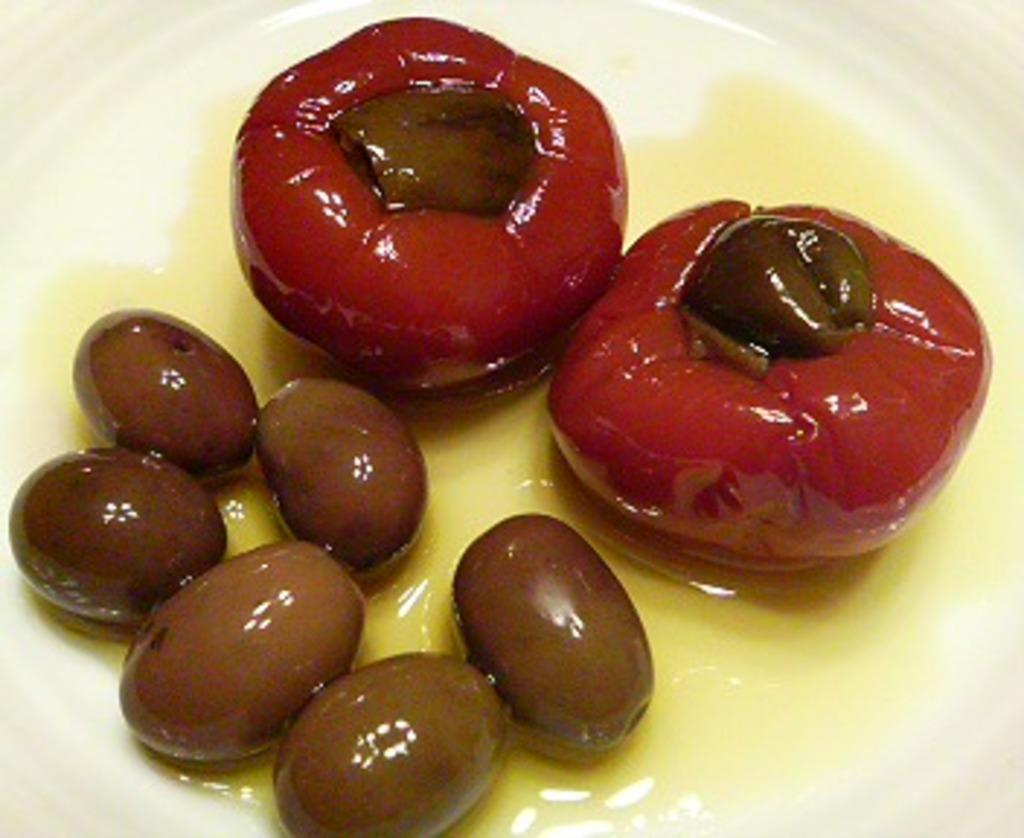What colors are the sweets on the plate in the image? The sweets on the plate are red and brown in color. What is the color of the plate? The plate is white in color. What is the color of the background in the image? The background of the image is white. How many legs can be seen supporting the plate in the image? There are no legs visible in the image, as the plate is likely resting on a surface. What type of knife is being used to cut the sweets in the image? There is no knife present in the image, and the sweets are not being cut. 